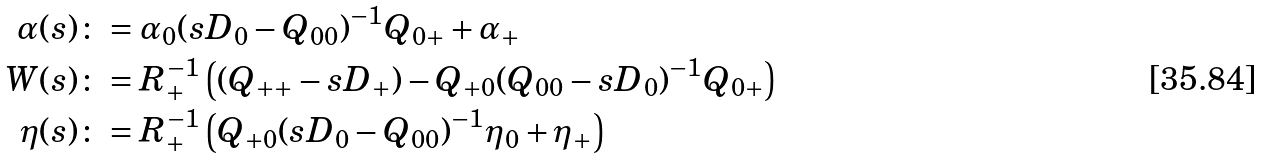Convert formula to latex. <formula><loc_0><loc_0><loc_500><loc_500>\alpha ( s ) & \colon = \alpha _ { 0 } ( s D _ { 0 } - Q _ { 0 0 } ) ^ { - 1 } Q _ { 0 + } + \alpha _ { + } \\ W ( s ) & \colon = R _ { + } ^ { - 1 } \left ( ( Q _ { + + } - s D _ { + } ) - Q _ { + 0 } ( Q _ { 0 0 } - s D _ { 0 } ) ^ { - 1 } Q _ { 0 + } \right ) \\ \eta ( s ) & \colon = R _ { + } ^ { - 1 } \left ( Q _ { + 0 } ( s D _ { 0 } - Q _ { 0 0 } ) ^ { - 1 } \eta _ { 0 } + \eta _ { + } \right )</formula> 